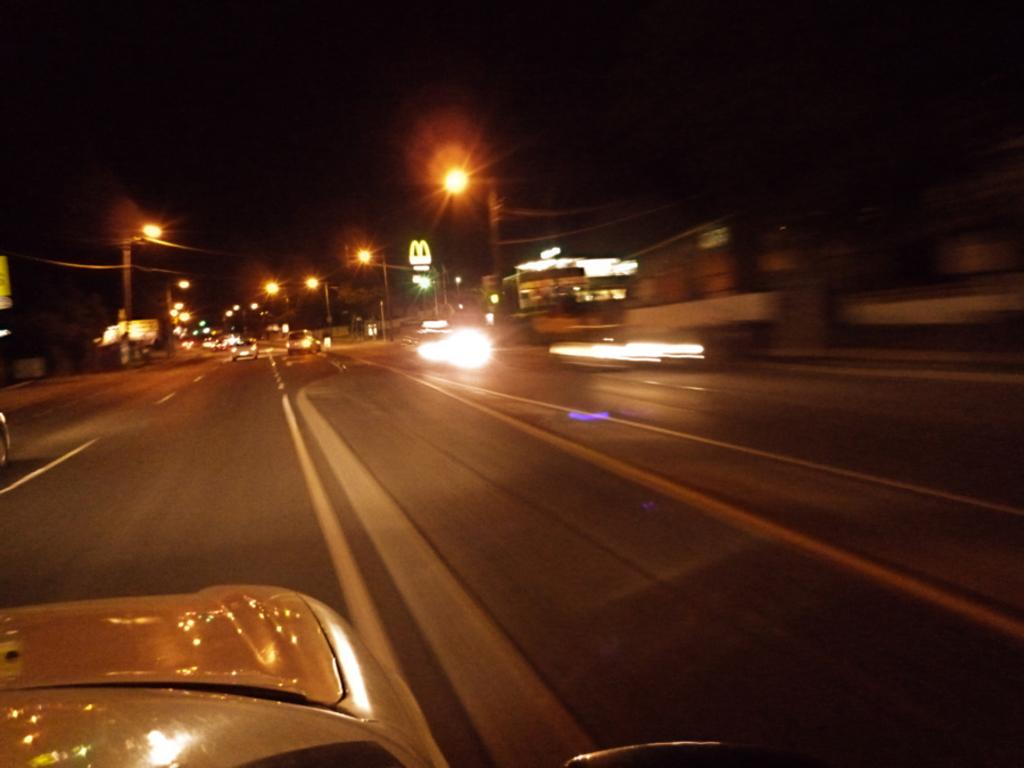What is happening on the road in the image? There are vehicles moving on the road in the image. Where are the vehicles located? The vehicles are on a road. What can be seen beside the road in the image? There are houses beside the road in the image. What type of signs or notices are visible in the image? There are boards visible in the image. What helps to illuminate the road at night in the image? There are street lights in the image. What type of humor can be seen in the oven in the image? There is no oven present in the image, and therefore no humor can be observed. 